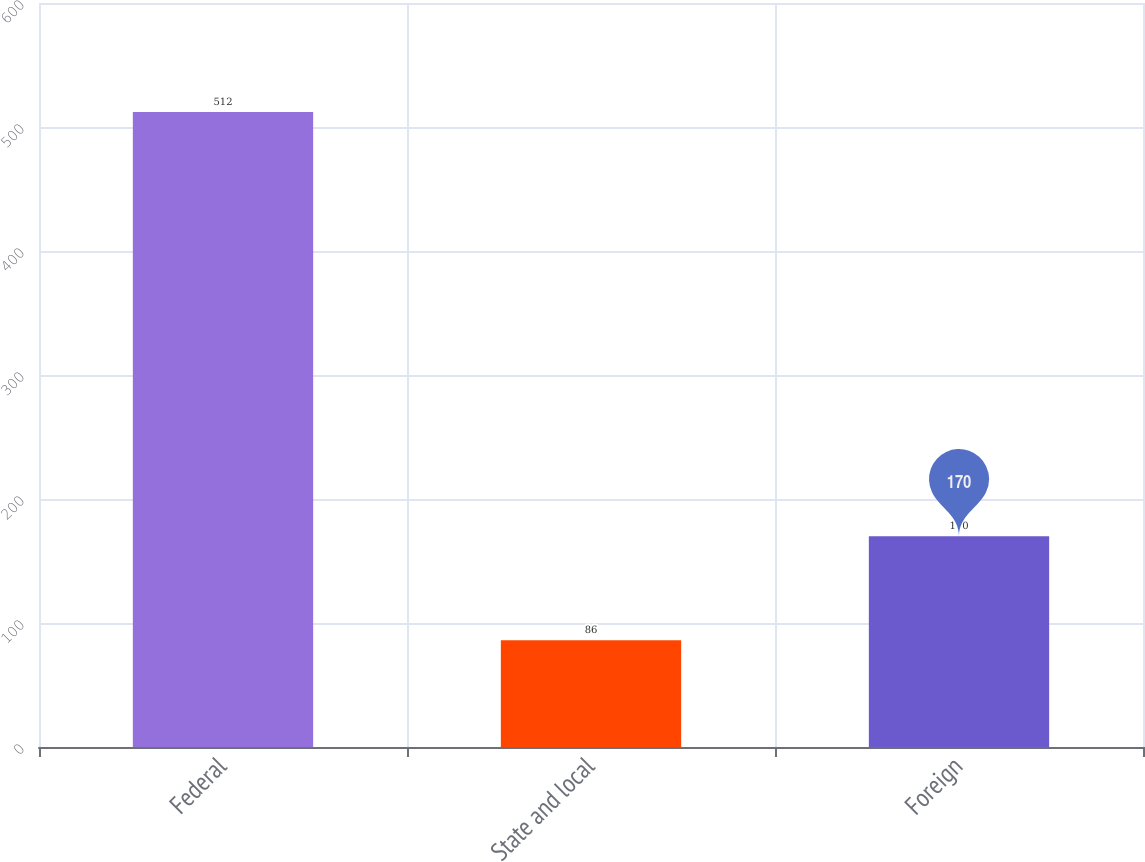<chart> <loc_0><loc_0><loc_500><loc_500><bar_chart><fcel>Federal<fcel>State and local<fcel>Foreign<nl><fcel>512<fcel>86<fcel>170<nl></chart> 